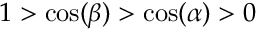<formula> <loc_0><loc_0><loc_500><loc_500>1 > \cos ( \beta ) > \cos ( \alpha ) > 0</formula> 